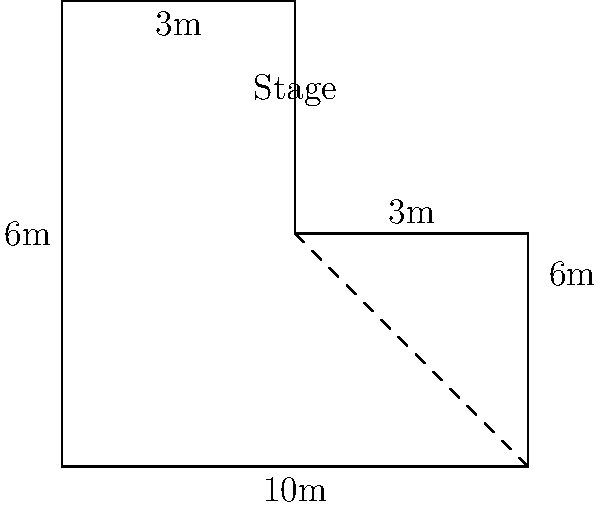For an exclusive meet-and-greet event with a popular artist, you've designed a winding queue line around the stage area. The queue forms a shape as shown in the diagram. If the total length of rope needed for the queue is equal to the perimeter of this shape, how many meters of rope should you order? To find the perimeter of the shape, we need to add up the lengths of all sides:

1. Bottom side: $10$ m
2. Right side: $6$ m
3. Upper-right side: $3$ m
4. Upper-left side: $3$ m
5. Left side: $6$ m

Calculate the total:
$$\text{Perimeter} = 10 \text{ m} + 6 \text{ m} + 3 \text{ m} + 3 \text{ m} + 6 \text{ m} = 28 \text{ m}$$

Therefore, you should order 28 meters of rope for the queue line.
Answer: 28 meters 